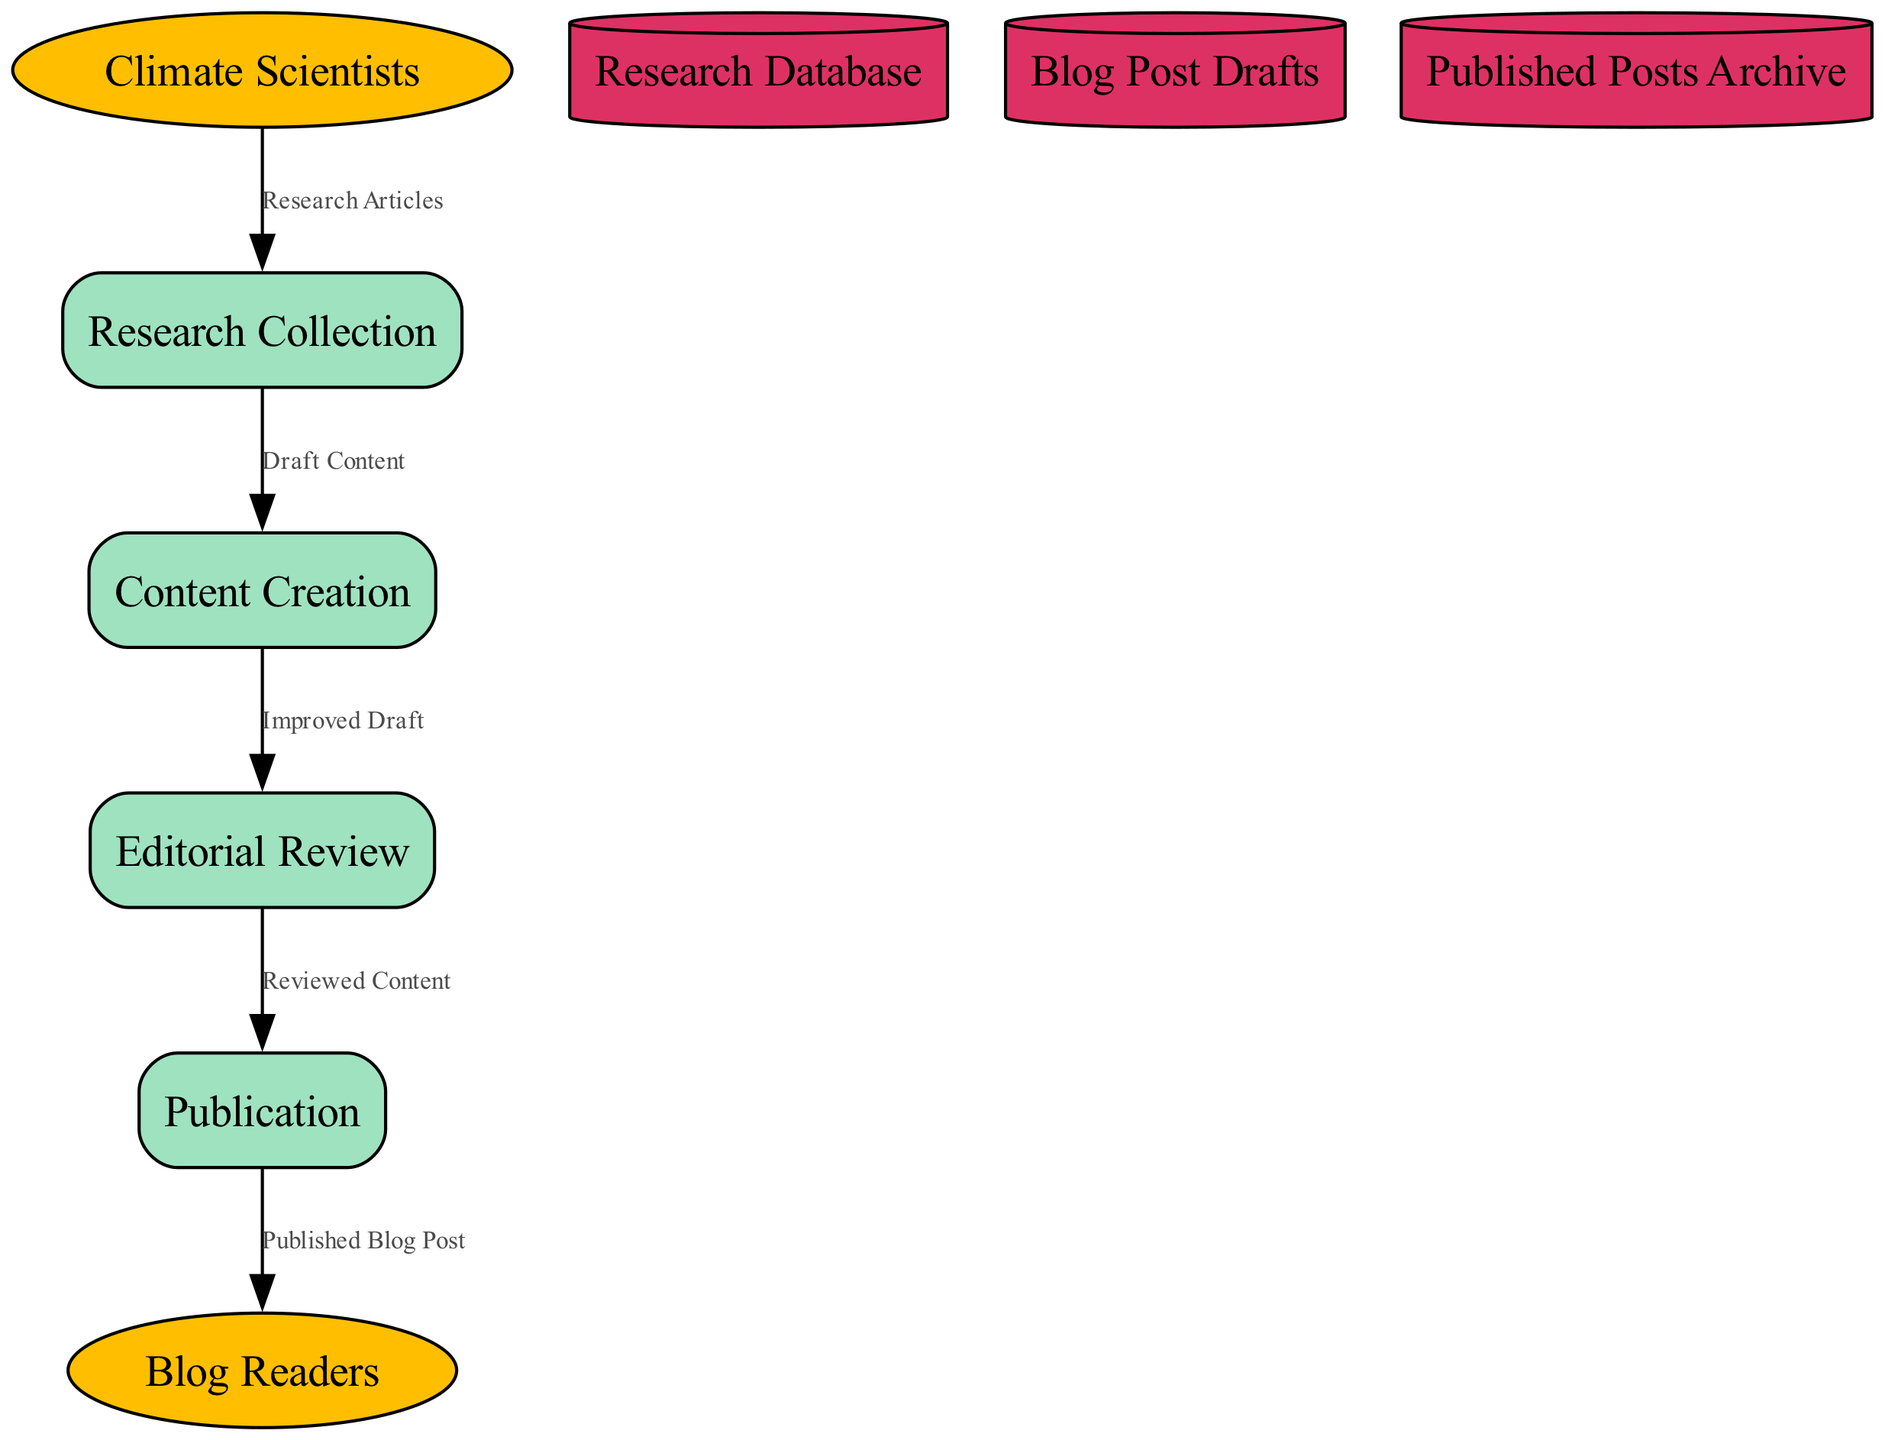What is the first process in the workflow? The first process is "Research Collection," which is the initial step where articles, data, and papers are gathered from various sources before further processing.
Answer: Research Collection How many external entities are present in the diagram? There are two external entities: "Blog Readers" and "Climate Scientists." These entities represent the key groups interacting with the blog's workflow.
Answer: 2 Which process is responsible for preparing blog posts for publication? The process responsible for preparing blog posts for publication is "Editorial Review," where the drafts are reviewed and edited to ensure quality, enabling a polished publication.
Answer: Editorial Review What type of data store is used for storing published content? The type of data store used for storing published content is "Published Posts Archive," which serves as an archive for all previously published blog posts and acts as a reference point.
Answer: Published Posts Archive From which external entity do research articles flow into the workflow? Research articles flow from the "Climate Scientists," who provide vital information and data needed for the research collection process.
Answer: Climate Scientists What is the final output of the publication process? The final output of the publication process is the "Published Blog Post," which represents the completed piece of content available for readers after being published.
Answer: Published Blog Post How many distinct processes are involved in the workflow? There are four distinct processes involved in the workflow: "Research Collection," "Content Creation," "Editorial Review," and "Publication." Each of these processes serves a unique function in the overall workflow.
Answer: 4 Which data flow comes from the "Content Creation" process? The data flow that comes from the "Content Creation" process is "Improved Draft," which represents the draft blog post that is sent for editorial review after being initially created.
Answer: Improved Draft What does the "Draft Content" data flow represent? The "Draft Content" data flow represents the gathered research data used for creating initial drafts of blog posts, transitioning from research collection to the content creation process.
Answer: Draft Content 